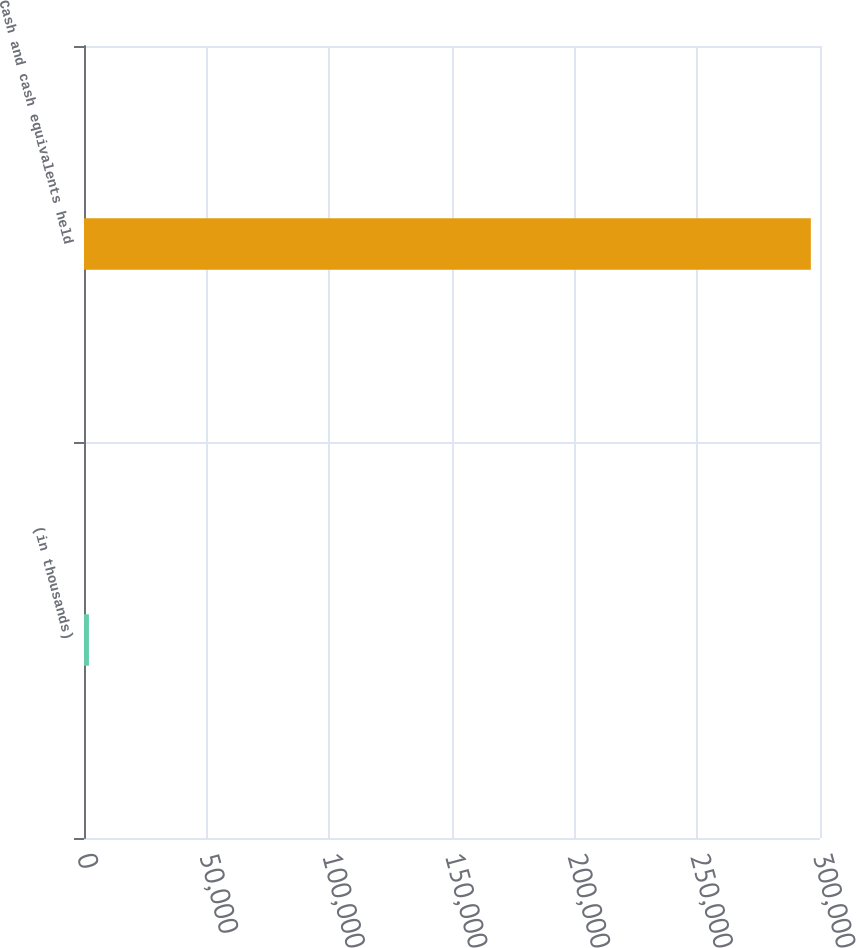Convert chart. <chart><loc_0><loc_0><loc_500><loc_500><bar_chart><fcel>(in thousands)<fcel>Cash and cash equivalents held<nl><fcel>2012<fcel>296270<nl></chart> 